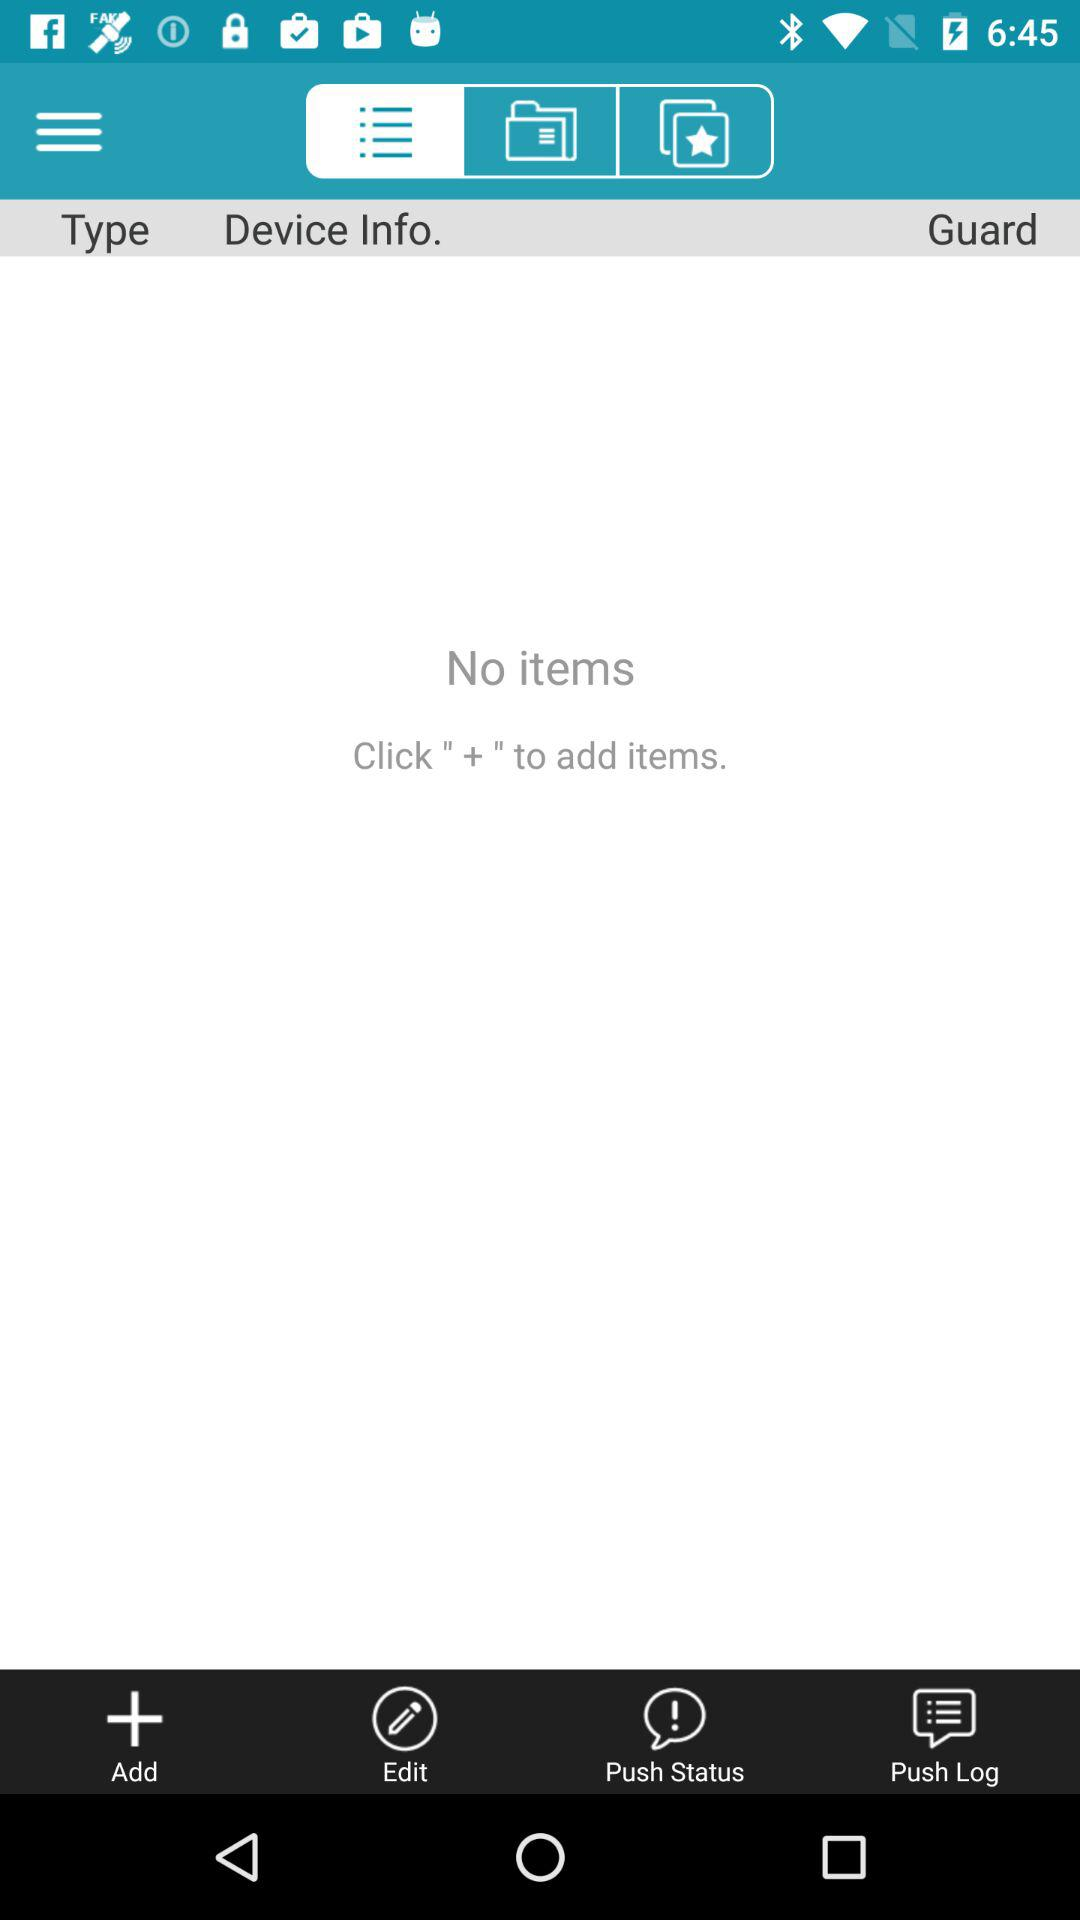How many notifications are there in "Push Status"?
When the provided information is insufficient, respond with <no answer>. <no answer> 